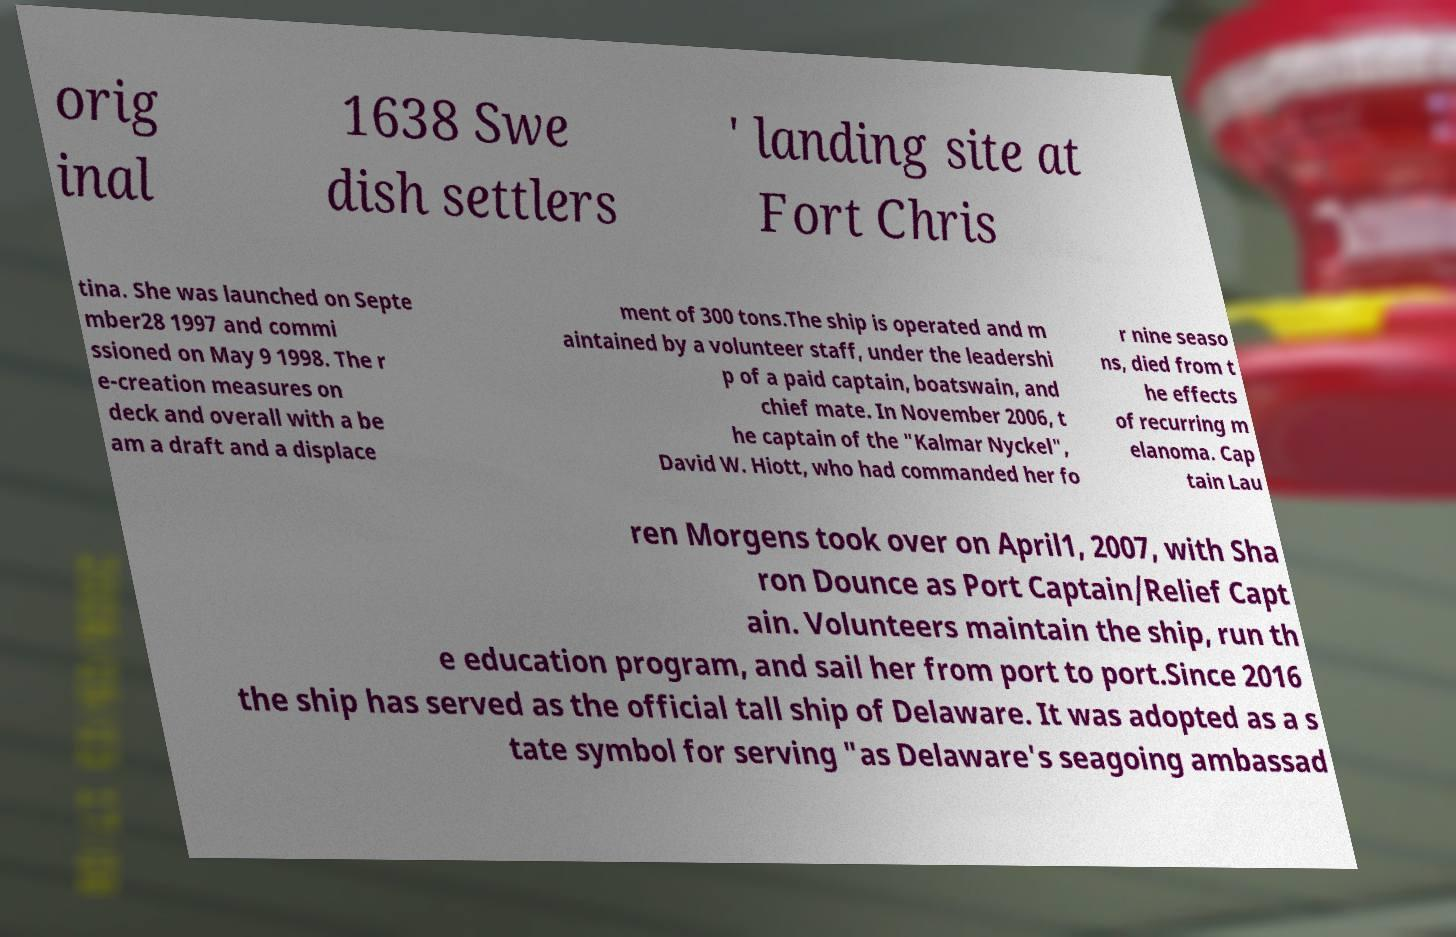I need the written content from this picture converted into text. Can you do that? orig inal 1638 Swe dish settlers ' landing site at Fort Chris tina. She was launched on Septe mber28 1997 and commi ssioned on May 9 1998. The r e-creation measures on deck and overall with a be am a draft and a displace ment of 300 tons.The ship is operated and m aintained by a volunteer staff, under the leadershi p of a paid captain, boatswain, and chief mate. In November 2006, t he captain of the "Kalmar Nyckel", David W. Hiott, who had commanded her fo r nine seaso ns, died from t he effects of recurring m elanoma. Cap tain Lau ren Morgens took over on April1, 2007, with Sha ron Dounce as Port Captain/Relief Capt ain. Volunteers maintain the ship, run th e education program, and sail her from port to port.Since 2016 the ship has served as the official tall ship of Delaware. It was adopted as a s tate symbol for serving "as Delaware's seagoing ambassad 